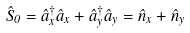Convert formula to latex. <formula><loc_0><loc_0><loc_500><loc_500>\hat { S } _ { 0 } = \hat { a } ^ { \dagger } _ { x } \hat { a } _ { x } + \hat { a } ^ { \dagger } _ { y } \hat { a } _ { y } = \hat { n } _ { x } + \hat { n } _ { y }</formula> 